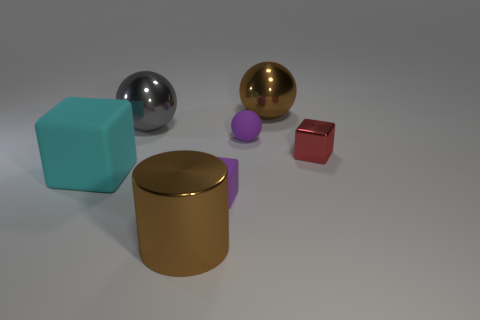How many things are either brown spheres or metallic balls that are to the left of the cylinder? In the image, I identify one brown sphere and one metallic ball on the left side of the gold cylinder. Thus, there are two objects that meet the criteria of either being brown spheres or metallic balls to the left of the cylinder. 